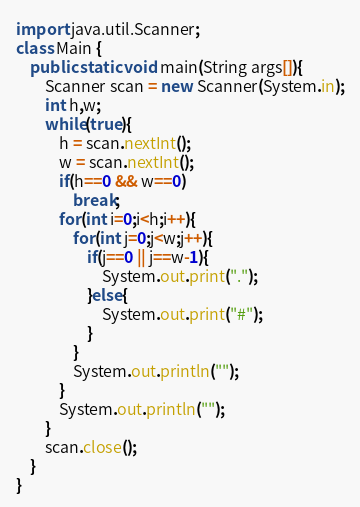Convert code to text. <code><loc_0><loc_0><loc_500><loc_500><_Java_>import java.util.Scanner;
class Main {
	public static void main(String args[]){
		Scanner scan = new Scanner(System.in);
		int h,w;
		while(true){
			h = scan.nextInt();
			w = scan.nextInt();
			if(h==0 && w==0)
				break;
			for(int i=0;i<h;i++){
				for(int j=0;j<w;j++){
					if(j==0 || j==w-1){
						System.out.print(".");
					}else{
						System.out.print("#");
					}
				}
				System.out.println("");
			}
			System.out.println("");
		}
		scan.close();
	}
}</code> 